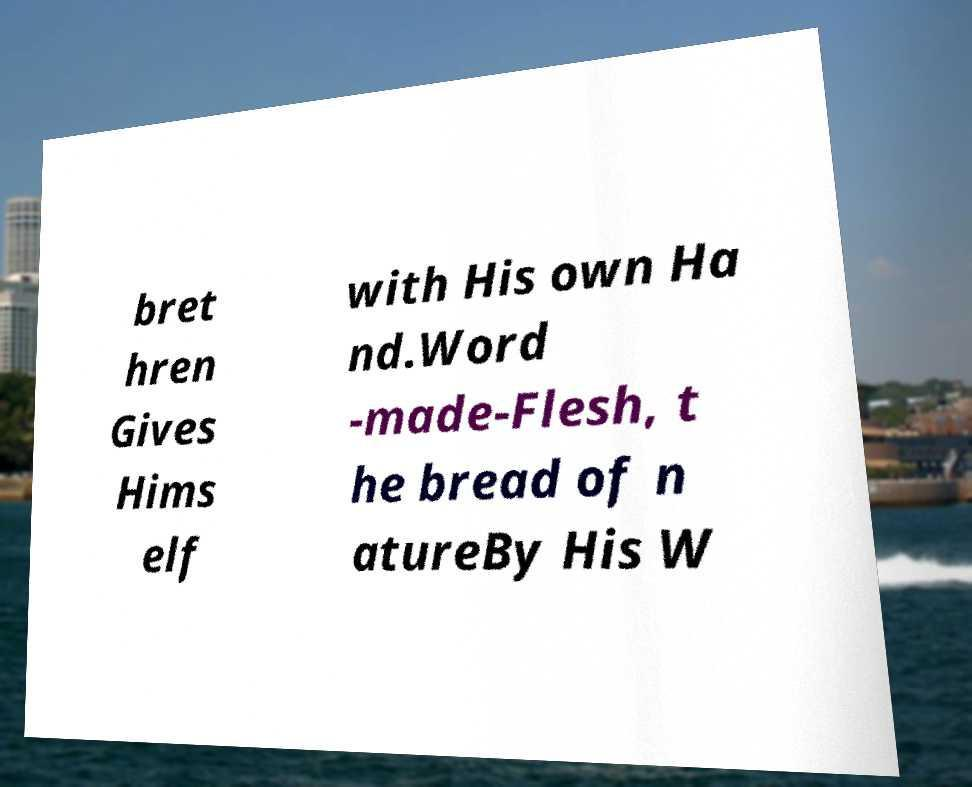Could you extract and type out the text from this image? bret hren Gives Hims elf with His own Ha nd.Word -made-Flesh, t he bread of n atureBy His W 